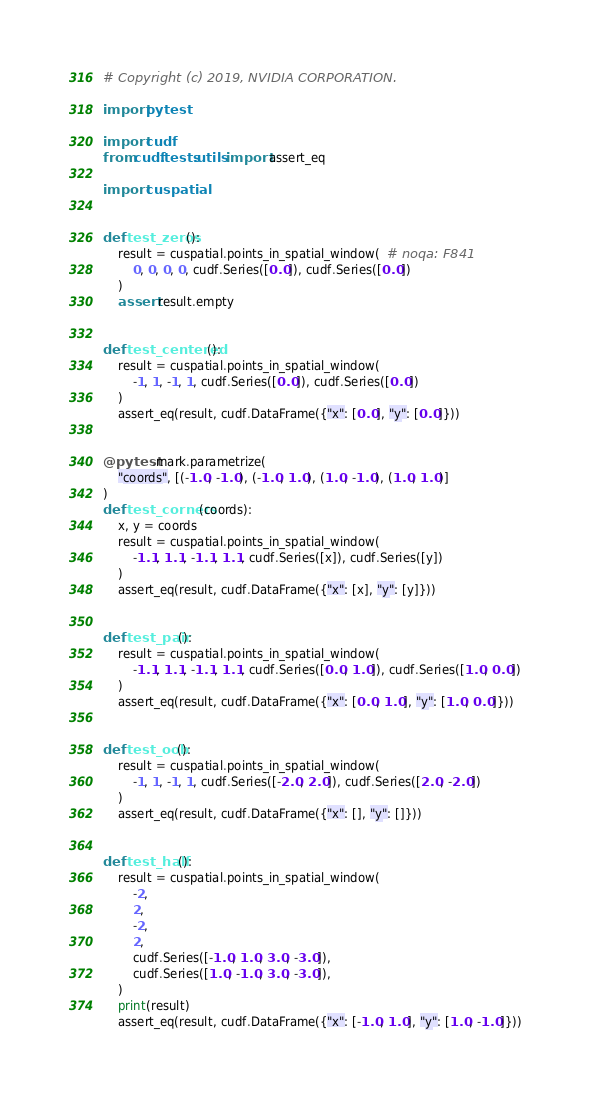<code> <loc_0><loc_0><loc_500><loc_500><_Python_># Copyright (c) 2019, NVIDIA CORPORATION.

import pytest

import cudf
from cudf.tests.utils import assert_eq

import cuspatial


def test_zeros():
    result = cuspatial.points_in_spatial_window(  # noqa: F841
        0, 0, 0, 0, cudf.Series([0.0]), cudf.Series([0.0])
    )
    assert result.empty


def test_centered():
    result = cuspatial.points_in_spatial_window(
        -1, 1, -1, 1, cudf.Series([0.0]), cudf.Series([0.0])
    )
    assert_eq(result, cudf.DataFrame({"x": [0.0], "y": [0.0]}))


@pytest.mark.parametrize(
    "coords", [(-1.0, -1.0), (-1.0, 1.0), (1.0, -1.0), (1.0, 1.0)]
)
def test_corners(coords):
    x, y = coords
    result = cuspatial.points_in_spatial_window(
        -1.1, 1.1, -1.1, 1.1, cudf.Series([x]), cudf.Series([y])
    )
    assert_eq(result, cudf.DataFrame({"x": [x], "y": [y]}))


def test_pair():
    result = cuspatial.points_in_spatial_window(
        -1.1, 1.1, -1.1, 1.1, cudf.Series([0.0, 1.0]), cudf.Series([1.0, 0.0])
    )
    assert_eq(result, cudf.DataFrame({"x": [0.0, 1.0], "y": [1.0, 0.0]}))


def test_oob():
    result = cuspatial.points_in_spatial_window(
        -1, 1, -1, 1, cudf.Series([-2.0, 2.0]), cudf.Series([2.0, -2.0])
    )
    assert_eq(result, cudf.DataFrame({"x": [], "y": []}))


def test_half():
    result = cuspatial.points_in_spatial_window(
        -2,
        2,
        -2,
        2,
        cudf.Series([-1.0, 1.0, 3.0, -3.0]),
        cudf.Series([1.0, -1.0, 3.0, -3.0]),
    )
    print(result)
    assert_eq(result, cudf.DataFrame({"x": [-1.0, 1.0], "y": [1.0, -1.0]}))
</code> 